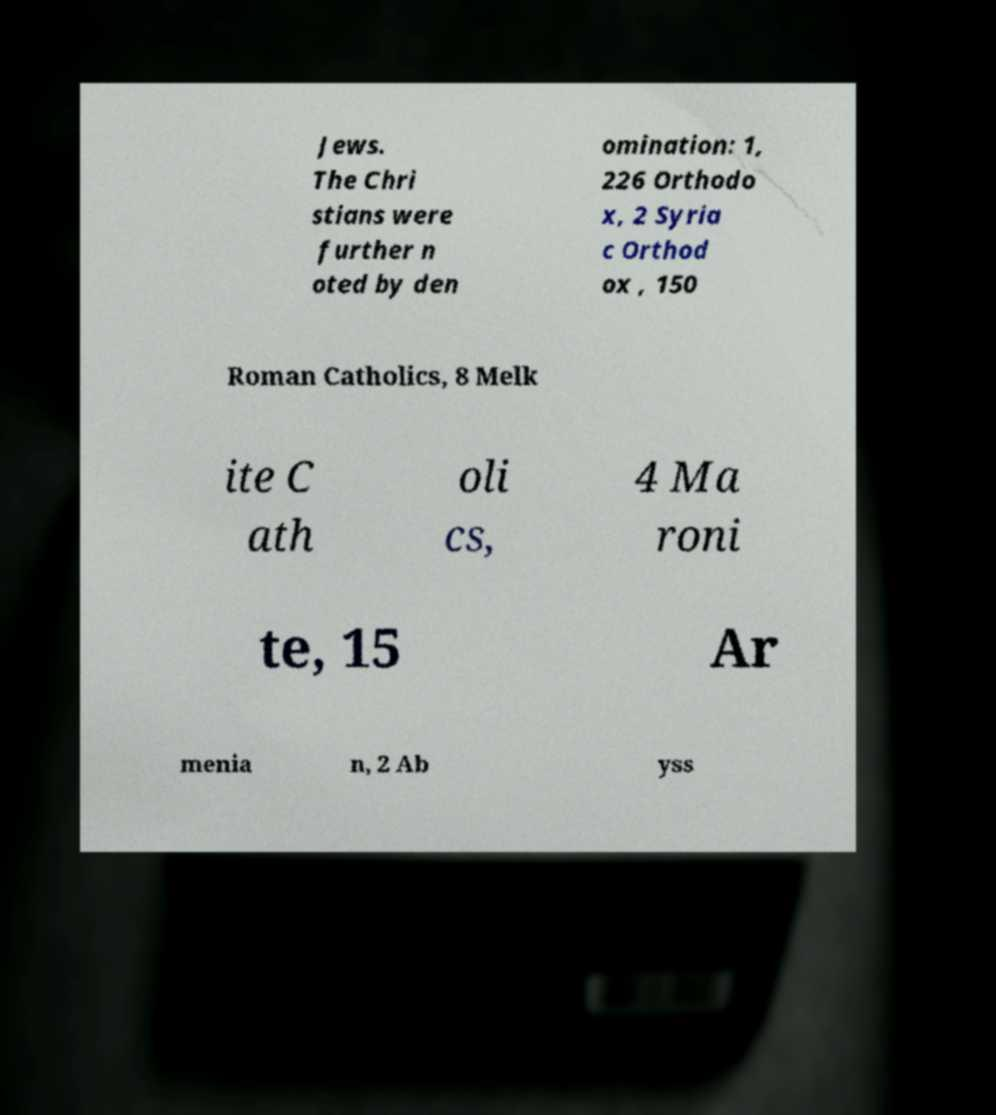What messages or text are displayed in this image? I need them in a readable, typed format. Jews. The Chri stians were further n oted by den omination: 1, 226 Orthodo x, 2 Syria c Orthod ox , 150 Roman Catholics, 8 Melk ite C ath oli cs, 4 Ma roni te, 15 Ar menia n, 2 Ab yss 